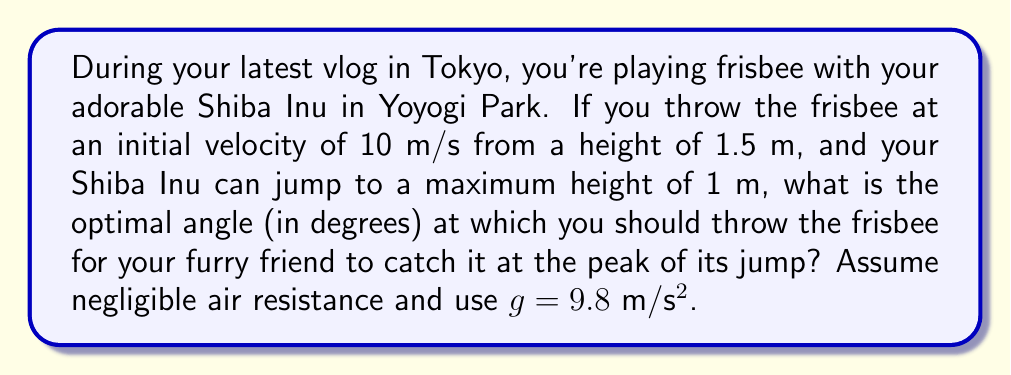What is the answer to this math problem? Let's approach this step-by-step:

1) The optimal angle for the dog to catch the frisbee is when the frisbee reaches its maximum height at the same time the dog reaches its maximum jump height.

2) The maximum height of the frisbee's trajectory should be:
   $h_{max} = 1.5m + 1m = 2.5m$

3) For a projectile, the maximum height is given by:
   $$h_{max} = h_0 + \frac{v_0^2 \sin^2 \theta}{2g}$$
   Where $h_0$ is the initial height, $v_0$ is the initial velocity, $\theta$ is the launch angle, and $g$ is the acceleration due to gravity.

4) Substituting our known values:
   $$2.5 = 1.5 + \frac{10^2 \sin^2 \theta}{2(9.8)}$$

5) Simplifying:
   $$1 = \frac{100 \sin^2 \theta}{19.6}$$
   $$19.6 = 100 \sin^2 \theta$$
   $$0.196 = \sin^2 \theta$$

6) Taking the square root of both sides:
   $$\sqrt{0.196} = \sin \theta$$
   $$0.4427 = \sin \theta$$

7) Taking the inverse sine (arcsin) of both sides:
   $$\theta = \arcsin(0.4427)$$

8) Converting to degrees:
   $$\theta = 26.3°$$

Thus, the optimal angle to throw the frisbee is approximately 26.3 degrees.
Answer: 26.3° 